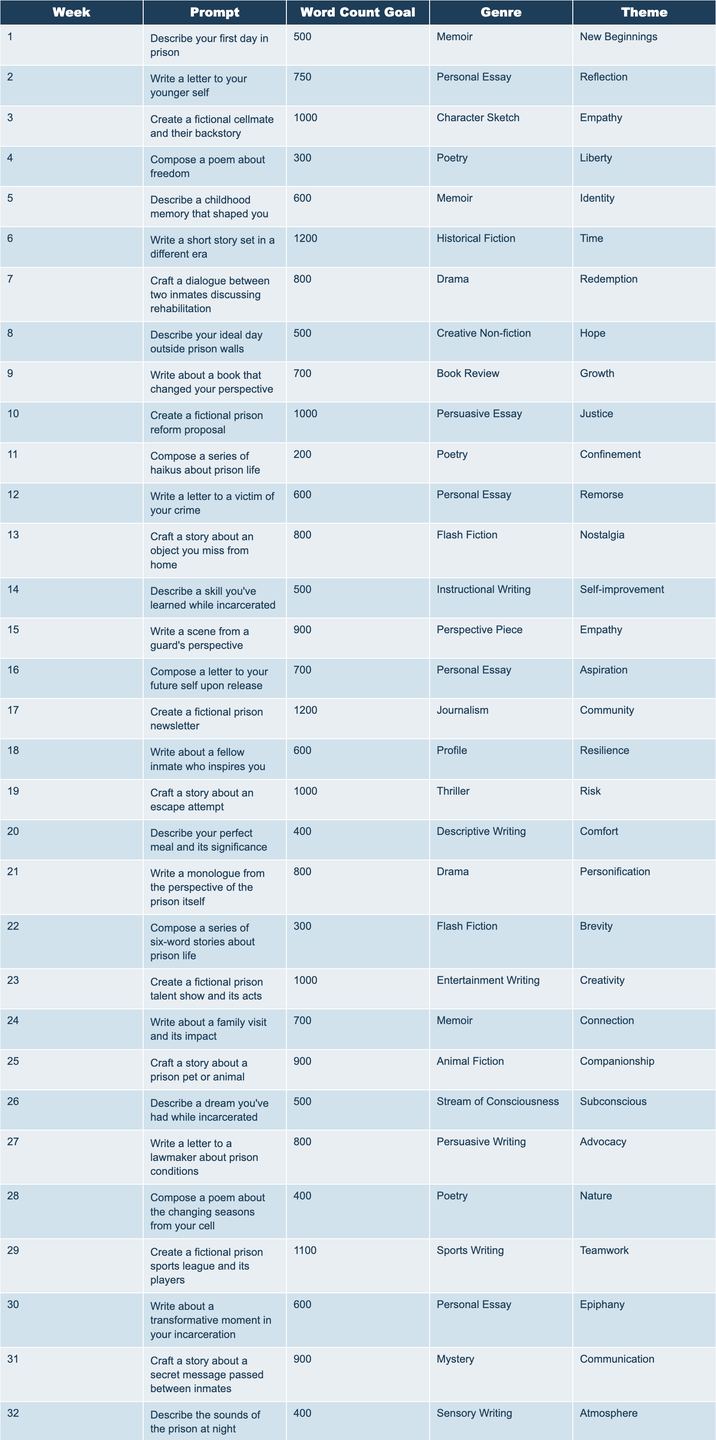What is the word count goal for the prompt to "Compose a poem about freedom"? The table indicates that the word count goal for this prompt is specified in the "Word Count Goal" column. For the prompt "Compose a poem about freedom," the value is 300.
Answer: 300 How many prompts have a word count goal of 1000 words? By scanning through the "Word Count Goal" column, we can count up all instances of 1000. The prompts with a 1000-word goal are: "Create a fictional cellmate and their backstory," "Create a fictional prison reform proposal," "Create a fictional prison talent show and its acts," "Craft a story about a prison pen pal relationship," and "Create a fictional prison library and its most popular books." This gives us a total of 5.
Answer: 5 Which genre has the highest frequency in the table? To determine the genre with the highest frequency, we check each genre's occurrence in the "Genre" column. Upon tallying, the genres appear as follows: Personal Essay (5), Poetry (9), Memoir (6), etc. By comparing these counts, we find that "Poetry," appearing 9 times, is the most frequent.
Answer: Poetry Are there any prompts that focus on the theme of "Redemption"? We look through the "Theme" column to check for the presence of the theme "Redemption." The prompts that include this theme are: "Craft a dialogue between two inmates discussing rehabilitation." From this analysis, we conclude that there is 1 prompt focusing on this theme.
Answer: Yes What is the total word count goal for all prompts categorized under the "Personal Essay" genre? We first identify the different prompts under the "Personal Essay" genre: "Write a letter to your younger self" (750), "Write a letter to a victim of your crime" (600), "Compose a letter to your future self upon release" (700), "Write a letter to your victim's family" (600), and "Write a letter to your future employer explaining your incarceration" (600). We sum these values: 750 + 600 + 700 + 600 + 600 = 3250.
Answer: 3250 Which prompt has the highest word count goal? To find the prompt with the highest word count goal, we review all the entries in the "Word Count Goal" column. The maximum value found is 1200, associated with "Write a short story set in a different era" and "Compose a story about a prison cooking competition," making both prompts the highest.
Answer: 1200 How many prompts have a word count goal under 500? In analyzing the "Word Count Goal" column, we look for values less than 500. The only prompt with a goal under 500 is "Compose a series of haikus about prison life," which has a goal of 200. Therefore, there is only 1 prompt that fits this criterion.
Answer: 1 What is the average word count goal for prompts related to the theme "Connection"? The relevant prompts under the "Connection" theme are: "Write about a family visit and its impact" (700) and "Craft a story about a prison pen pal relationship" (1000). First, we calculate the sum: 700 + 1000 = 1700, then we divide by 2 (the number of prompts) which gives us an average of 850.
Answer: 850 